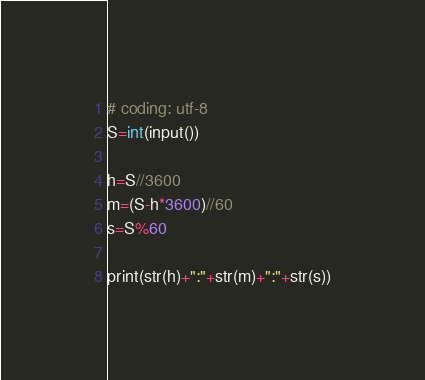Convert code to text. <code><loc_0><loc_0><loc_500><loc_500><_C++_># coding: utf-8
S=int(input())

h=S//3600
m=(S-h*3600)//60
s=S%60

print(str(h)+":"+str(m)+":"+str(s))</code> 